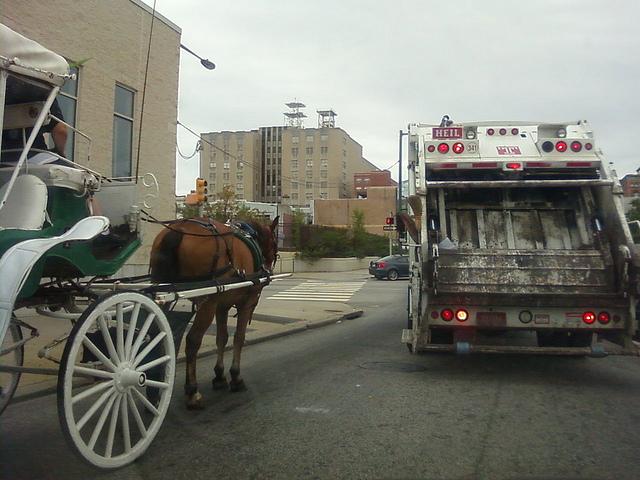What's behind the horse?
Concise answer only. Carriage. What does the bumper say?
Write a very short answer. Heil. How many oxen are in the photo?
Keep it brief. 0. How many cars are behind the horse carriage?
Concise answer only. 0. What type of truck is in this picture?
Quick response, please. Garbage. Is this picture in color?
Keep it brief. Yes. What keeps the horse from running away?
Quick response, please. Carriage. How many cars are in the picture?
Write a very short answer. 1. 